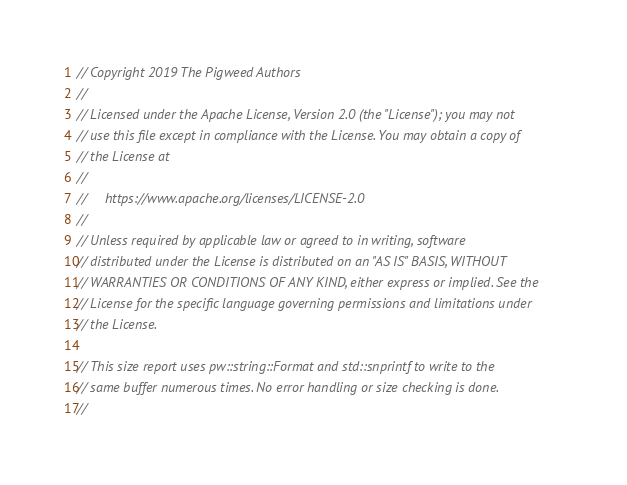Convert code to text. <code><loc_0><loc_0><loc_500><loc_500><_C++_>// Copyright 2019 The Pigweed Authors
//
// Licensed under the Apache License, Version 2.0 (the "License"); you may not
// use this file except in compliance with the License. You may obtain a copy of
// the License at
//
//     https://www.apache.org/licenses/LICENSE-2.0
//
// Unless required by applicable law or agreed to in writing, software
// distributed under the License is distributed on an "AS IS" BASIS, WITHOUT
// WARRANTIES OR CONDITIONS OF ANY KIND, either express or implied. See the
// License for the specific language governing permissions and limitations under
// the License.

// This size report uses pw::string::Format and std::snprintf to write to the
// same buffer numerous times. No error handling or size checking is done.
//</code> 